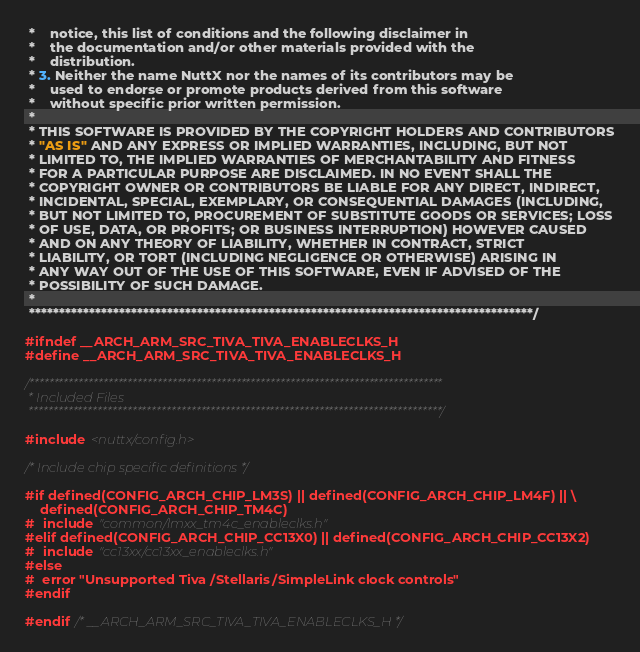Convert code to text. <code><loc_0><loc_0><loc_500><loc_500><_C_> *    notice, this list of conditions and the following disclaimer in
 *    the documentation and/or other materials provided with the
 *    distribution.
 * 3. Neither the name NuttX nor the names of its contributors may be
 *    used to endorse or promote products derived from this software
 *    without specific prior written permission.
 *
 * THIS SOFTWARE IS PROVIDED BY THE COPYRIGHT HOLDERS AND CONTRIBUTORS
 * "AS IS" AND ANY EXPRESS OR IMPLIED WARRANTIES, INCLUDING, BUT NOT
 * LIMITED TO, THE IMPLIED WARRANTIES OF MERCHANTABILITY AND FITNESS
 * FOR A PARTICULAR PURPOSE ARE DISCLAIMED. IN NO EVENT SHALL THE
 * COPYRIGHT OWNER OR CONTRIBUTORS BE LIABLE FOR ANY DIRECT, INDIRECT,
 * INCIDENTAL, SPECIAL, EXEMPLARY, OR CONSEQUENTIAL DAMAGES (INCLUDING,
 * BUT NOT LIMITED TO, PROCUREMENT OF SUBSTITUTE GOODS OR SERVICES; LOSS
 * OF USE, DATA, OR PROFITS; OR BUSINESS INTERRUPTION) HOWEVER CAUSED
 * AND ON ANY THEORY OF LIABILITY, WHETHER IN CONTRACT, STRICT
 * LIABILITY, OR TORT (INCLUDING NEGLIGENCE OR OTHERWISE) ARISING IN
 * ANY WAY OUT OF THE USE OF THIS SOFTWARE, EVEN IF ADVISED OF THE
 * POSSIBILITY OF SUCH DAMAGE.
 *
 ************************************************************************************/

#ifndef __ARCH_ARM_SRC_TIVA_TIVA_ENABLECLKS_H
#define __ARCH_ARM_SRC_TIVA_TIVA_ENABLECLKS_H

/************************************************************************************
 * Included Files
 ************************************************************************************/

#include <nuttx/config.h>

/* Include chip specific definitions */

#if defined(CONFIG_ARCH_CHIP_LM3S) || defined(CONFIG_ARCH_CHIP_LM4F) || \
    defined(CONFIG_ARCH_CHIP_TM4C)
#  include "common/lmxx_tm4c_enableclks.h"
#elif defined(CONFIG_ARCH_CHIP_CC13X0) || defined(CONFIG_ARCH_CHIP_CC13X2)
#  include "cc13xx/cc13xx_enableclks.h"
#else
#  error "Unsupported Tiva/Stellaris/SimpleLink clock controls"
#endif

#endif /* __ARCH_ARM_SRC_TIVA_TIVA_ENABLECLKS_H */
</code> 